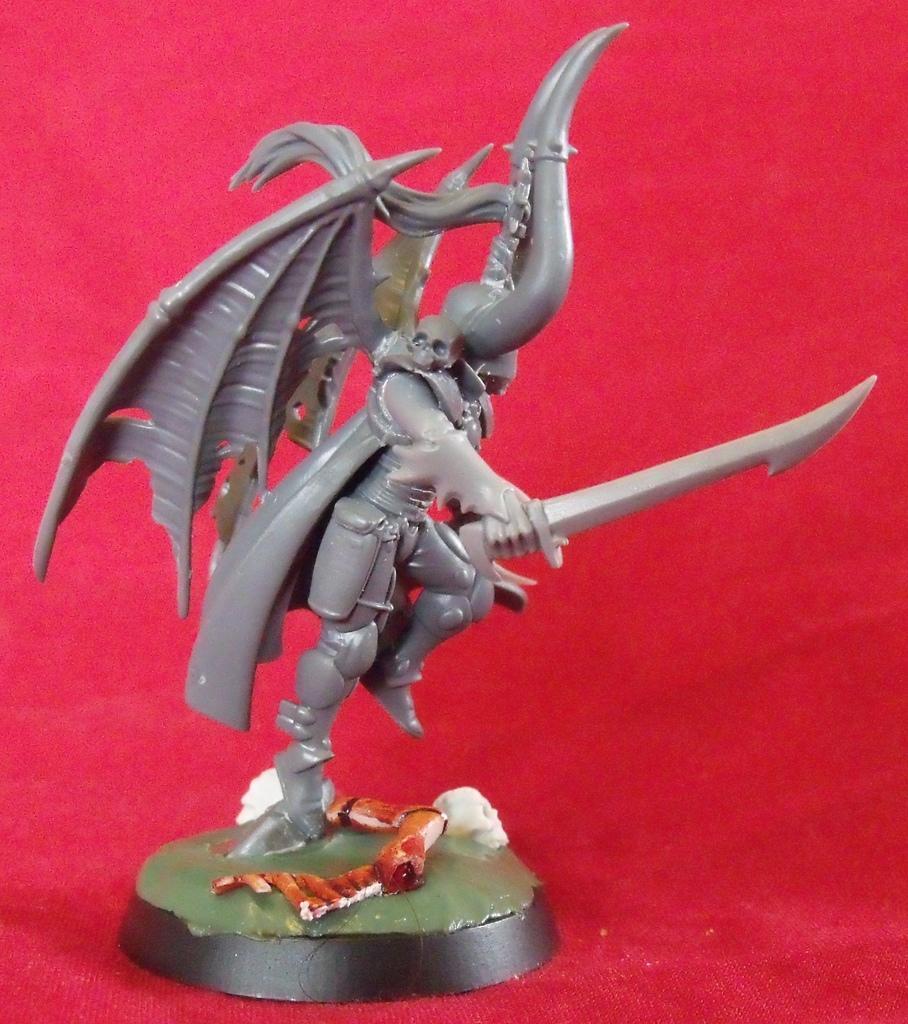How would you summarize this image in a sentence or two? In this image there is a statue and there is a curtain which is red in colour. 